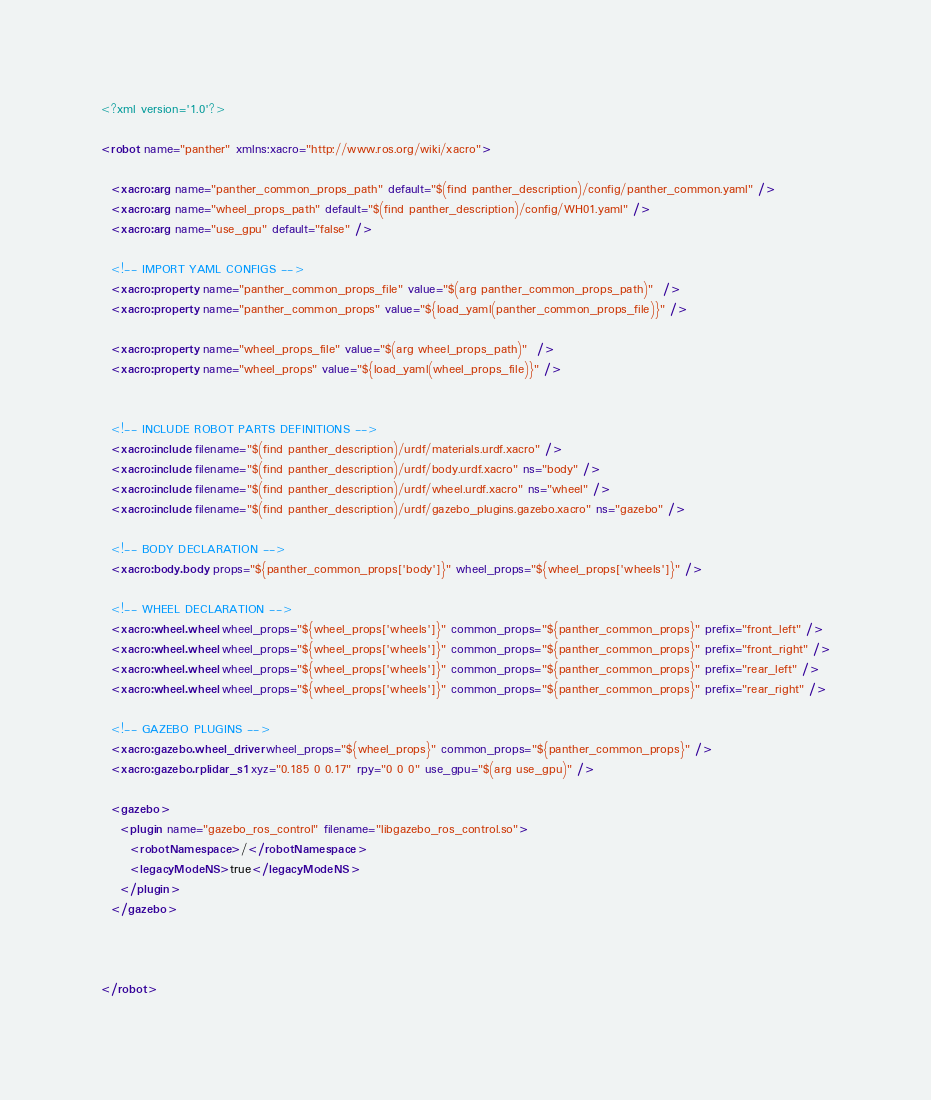Convert code to text. <code><loc_0><loc_0><loc_500><loc_500><_XML_><?xml version='1.0'?>

<robot name="panther" xmlns:xacro="http://www.ros.org/wiki/xacro">

  <xacro:arg name="panther_common_props_path" default="$(find panther_description)/config/panther_common.yaml" />
  <xacro:arg name="wheel_props_path" default="$(find panther_description)/config/WH01.yaml" />
  <xacro:arg name="use_gpu" default="false" />

  <!-- IMPORT YAML CONFIGS -->
  <xacro:property name="panther_common_props_file" value="$(arg panther_common_props_path)"  />
  <xacro:property name="panther_common_props" value="${load_yaml(panther_common_props_file)}" />

  <xacro:property name="wheel_props_file" value="$(arg wheel_props_path)"  />
  <xacro:property name="wheel_props" value="${load_yaml(wheel_props_file)}" />


  <!-- INCLUDE ROBOT PARTS DEFINITIONS -->
  <xacro:include filename="$(find panther_description)/urdf/materials.urdf.xacro" />
  <xacro:include filename="$(find panther_description)/urdf/body.urdf.xacro" ns="body" />
  <xacro:include filename="$(find panther_description)/urdf/wheel.urdf.xacro" ns="wheel" />
  <xacro:include filename="$(find panther_description)/urdf/gazebo_plugins.gazebo.xacro" ns="gazebo" />

  <!-- BODY DECLARATION -->
  <xacro:body.body props="${panther_common_props['body']}" wheel_props="${wheel_props['wheels']}" />

  <!-- WHEEL DECLARATION -->
  <xacro:wheel.wheel wheel_props="${wheel_props['wheels']}" common_props="${panther_common_props}" prefix="front_left" />
  <xacro:wheel.wheel wheel_props="${wheel_props['wheels']}" common_props="${panther_common_props}" prefix="front_right" />
  <xacro:wheel.wheel wheel_props="${wheel_props['wheels']}" common_props="${panther_common_props}" prefix="rear_left" />
  <xacro:wheel.wheel wheel_props="${wheel_props['wheels']}" common_props="${panther_common_props}" prefix="rear_right" />

  <!-- GAZEBO PLUGINS -->
  <xacro:gazebo.wheel_driver wheel_props="${wheel_props}" common_props="${panther_common_props}" />
  <xacro:gazebo.rplidar_s1 xyz="0.185 0 0.17" rpy="0 0 0" use_gpu="$(arg use_gpu)" />

  <gazebo>
    <plugin name="gazebo_ros_control" filename="libgazebo_ros_control.so">
      <robotNamespace>/</robotNamespace>
      <legacyModeNS>true</legacyModeNS>
    </plugin>
  </gazebo>



</robot>
</code> 